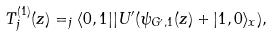<formula> <loc_0><loc_0><loc_500><loc_500>T ^ { ( 1 ) } _ { j } ( z ) = _ { j } \langle 0 , 1 | | U ^ { \prime } ( \psi _ { G ^ { \prime } , 1 } ( z ) + | 1 , 0 \rangle _ { x } ) ,</formula> 